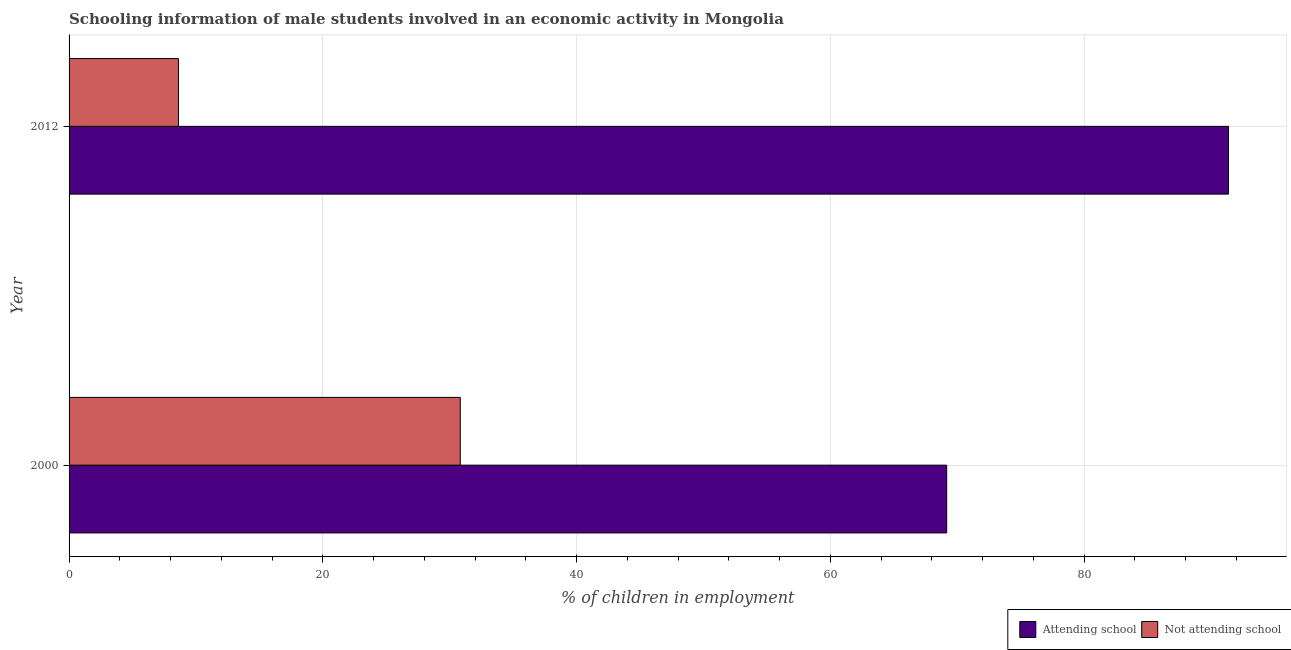How many different coloured bars are there?
Make the answer very short. 2. How many groups of bars are there?
Provide a succinct answer. 2. Are the number of bars per tick equal to the number of legend labels?
Provide a short and direct response. Yes. How many bars are there on the 1st tick from the bottom?
Offer a terse response. 2. In how many cases, is the number of bars for a given year not equal to the number of legend labels?
Offer a terse response. 0. What is the percentage of employed males who are not attending school in 2000?
Provide a short and direct response. 30.83. Across all years, what is the maximum percentage of employed males who are not attending school?
Offer a terse response. 30.83. Across all years, what is the minimum percentage of employed males who are attending school?
Your response must be concise. 69.17. In which year was the percentage of employed males who are attending school minimum?
Offer a very short reply. 2000. What is the total percentage of employed males who are attending school in the graph?
Ensure brevity in your answer.  160.55. What is the difference between the percentage of employed males who are attending school in 2000 and that in 2012?
Offer a very short reply. -22.21. What is the difference between the percentage of employed males who are attending school in 2000 and the percentage of employed males who are not attending school in 2012?
Provide a succinct answer. 60.55. What is the average percentage of employed males who are attending school per year?
Your response must be concise. 80.27. In the year 2000, what is the difference between the percentage of employed males who are not attending school and percentage of employed males who are attending school?
Your response must be concise. -38.34. In how many years, is the percentage of employed males who are not attending school greater than 28 %?
Keep it short and to the point. 1. What is the ratio of the percentage of employed males who are not attending school in 2000 to that in 2012?
Your answer should be compact. 3.58. Is the difference between the percentage of employed males who are not attending school in 2000 and 2012 greater than the difference between the percentage of employed males who are attending school in 2000 and 2012?
Provide a short and direct response. Yes. In how many years, is the percentage of employed males who are attending school greater than the average percentage of employed males who are attending school taken over all years?
Ensure brevity in your answer.  1. What does the 2nd bar from the top in 2000 represents?
Ensure brevity in your answer.  Attending school. What does the 1st bar from the bottom in 2000 represents?
Provide a short and direct response. Attending school. How many bars are there?
Provide a short and direct response. 4. What is the difference between two consecutive major ticks on the X-axis?
Provide a succinct answer. 20. Are the values on the major ticks of X-axis written in scientific E-notation?
Provide a succinct answer. No. Does the graph contain any zero values?
Provide a short and direct response. No. Where does the legend appear in the graph?
Your answer should be very brief. Bottom right. How are the legend labels stacked?
Provide a short and direct response. Horizontal. What is the title of the graph?
Offer a very short reply. Schooling information of male students involved in an economic activity in Mongolia. What is the label or title of the X-axis?
Your answer should be very brief. % of children in employment. What is the label or title of the Y-axis?
Make the answer very short. Year. What is the % of children in employment in Attending school in 2000?
Offer a terse response. 69.17. What is the % of children in employment of Not attending school in 2000?
Give a very brief answer. 30.83. What is the % of children in employment in Attending school in 2012?
Your answer should be compact. 91.38. What is the % of children in employment of Not attending school in 2012?
Keep it short and to the point. 8.62. Across all years, what is the maximum % of children in employment in Attending school?
Make the answer very short. 91.38. Across all years, what is the maximum % of children in employment in Not attending school?
Provide a succinct answer. 30.83. Across all years, what is the minimum % of children in employment of Attending school?
Offer a terse response. 69.17. Across all years, what is the minimum % of children in employment in Not attending school?
Provide a succinct answer. 8.62. What is the total % of children in employment of Attending school in the graph?
Provide a succinct answer. 160.55. What is the total % of children in employment in Not attending school in the graph?
Offer a terse response. 39.45. What is the difference between the % of children in employment in Attending school in 2000 and that in 2012?
Your response must be concise. -22.21. What is the difference between the % of children in employment in Not attending school in 2000 and that in 2012?
Your response must be concise. 22.21. What is the difference between the % of children in employment of Attending school in 2000 and the % of children in employment of Not attending school in 2012?
Your response must be concise. 60.55. What is the average % of children in employment in Attending school per year?
Keep it short and to the point. 80.27. What is the average % of children in employment in Not attending school per year?
Your answer should be very brief. 19.73. In the year 2000, what is the difference between the % of children in employment of Attending school and % of children in employment of Not attending school?
Offer a very short reply. 38.34. In the year 2012, what is the difference between the % of children in employment of Attending school and % of children in employment of Not attending school?
Provide a short and direct response. 82.76. What is the ratio of the % of children in employment of Attending school in 2000 to that in 2012?
Give a very brief answer. 0.76. What is the ratio of the % of children in employment of Not attending school in 2000 to that in 2012?
Your answer should be compact. 3.58. What is the difference between the highest and the second highest % of children in employment of Attending school?
Offer a terse response. 22.21. What is the difference between the highest and the second highest % of children in employment of Not attending school?
Make the answer very short. 22.21. What is the difference between the highest and the lowest % of children in employment in Attending school?
Your answer should be compact. 22.21. What is the difference between the highest and the lowest % of children in employment in Not attending school?
Provide a succinct answer. 22.21. 